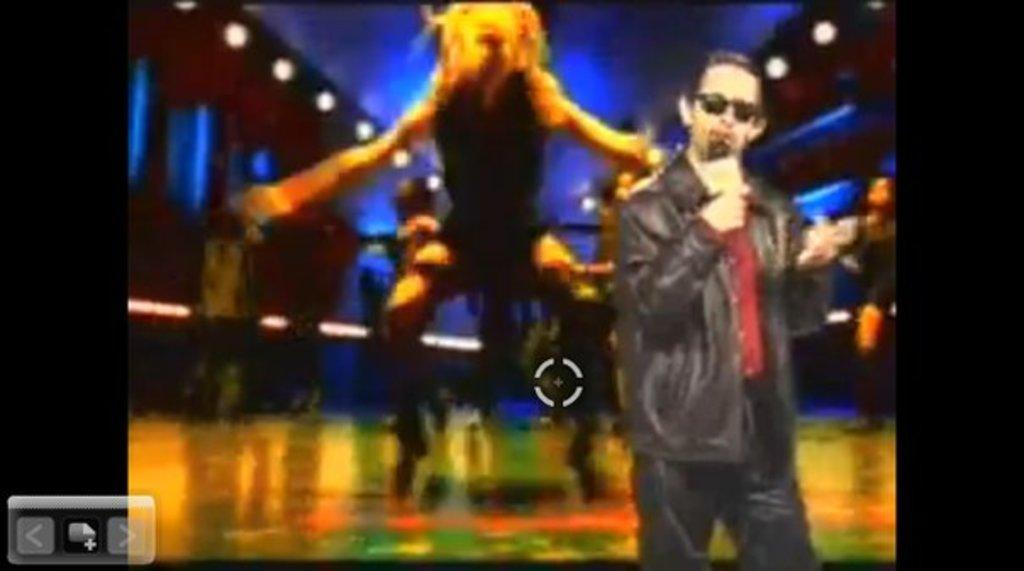What is the position of the man in the image? The man is standing on the right side of the image. What is the man wearing in the image? The man is wearing a jacket in the image. What can be seen in the middle of the image? There is a graphical image in the middle of the image. How many rabbits are hopping around the man in the image? There are no rabbits present in the image. What type of wax is being used to create the graphical image in the image? There is no information about the materials used to create the graphical image in the image. 